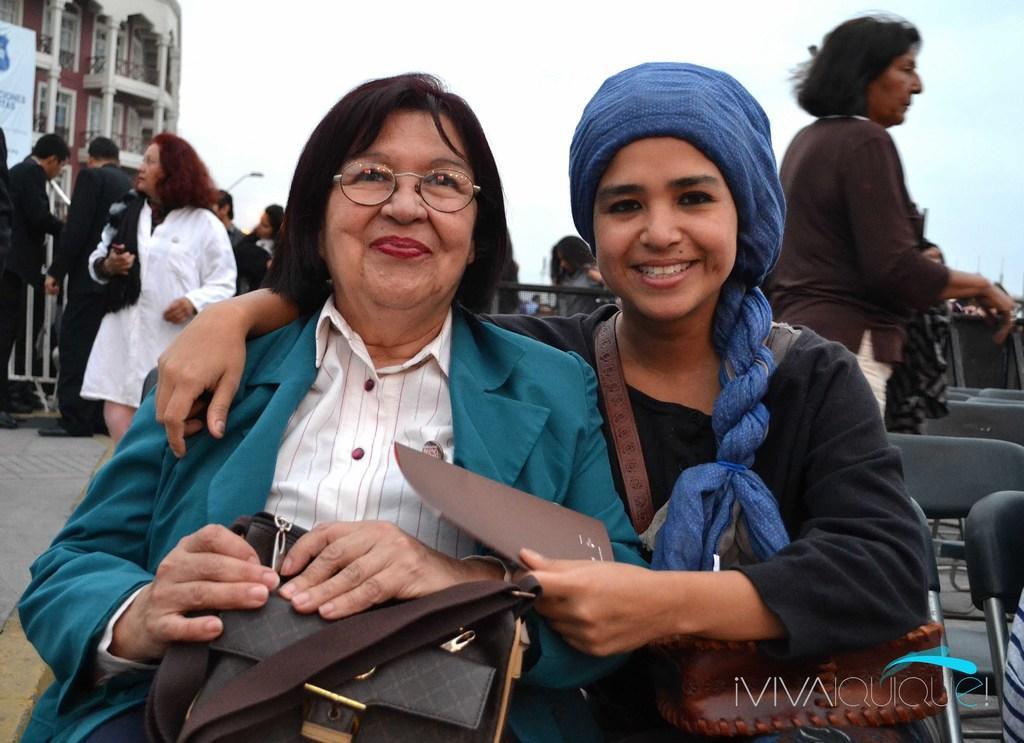How would you summarize this image in a sentence or two? In this picture we can see two women are sitting on chairs, they are smiling, in the background there are some people standing, on the left side we can see a building and a hoarding, we can see the sky at the top of the picture, a woman in the front is holding a bag. 